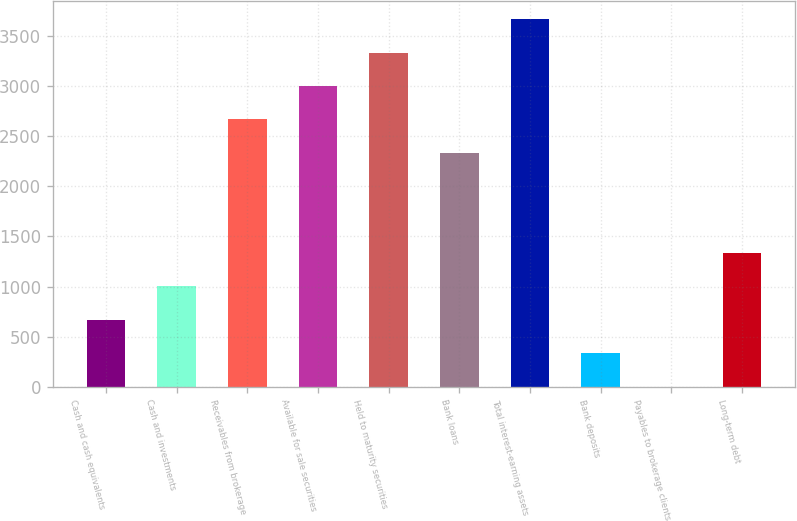Convert chart. <chart><loc_0><loc_0><loc_500><loc_500><bar_chart><fcel>Cash and cash equivalents<fcel>Cash and investments<fcel>Receivables from brokerage<fcel>Available for sale securities<fcel>Held to maturity securities<fcel>Bank loans<fcel>Total interest-earning assets<fcel>Bank deposits<fcel>Payables to brokerage clients<fcel>Long-term debt<nl><fcel>669<fcel>1002<fcel>2667<fcel>3000<fcel>3333<fcel>2334<fcel>3666<fcel>336<fcel>3<fcel>1335<nl></chart> 